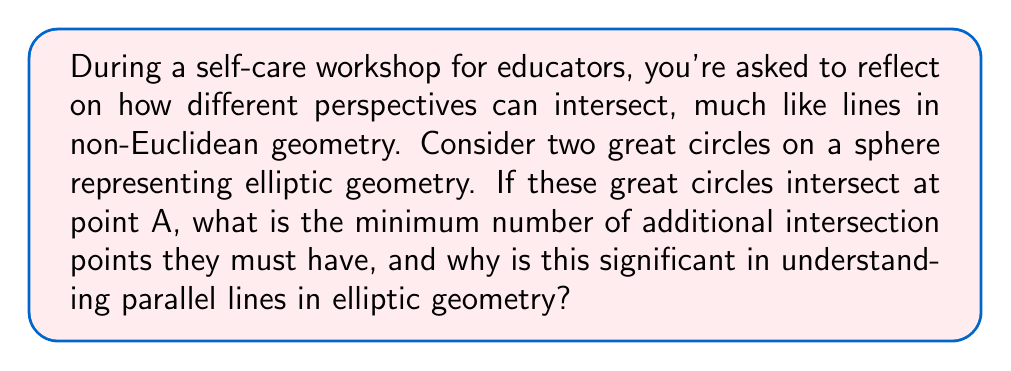Teach me how to tackle this problem. Let's approach this step-by-step:

1. In elliptic geometry, "straight lines" are represented by great circles on a sphere.

2. Two distinct great circles on a sphere always intersect at exactly two points. This is because:

   a) A great circle is formed by the intersection of a plane passing through the center of the sphere with the sphere's surface.
   
   b) Two distinct planes passing through the center of a sphere will always intersect in a line.
   
   c) This line of intersection will pierce the sphere's surface at exactly two points, which are antipodal (diametrically opposite).

3. Given that the two great circles already intersect at point A, there must be exactly one more intersection point, let's call it B, which is antipodal to A.

4. This property is significant in understanding parallel lines in elliptic geometry because:

   a) In Euclidean geometry, parallel lines never intersect.
   
   b) In elliptic geometry, the concept of parallel lines as we know it in Euclidean geometry doesn't exist.
   
   c) Any two "lines" (great circles) in elliptic geometry will always intersect at two points.

5. This can be represented mathematically. If we consider the sphere to have radius $r$ and center at the origin, and point A has coordinates $(x, y, z)$, then point B will have coordinates $(-x, -y, -z)$.

6. The angle $\theta$ between these great circles at their intersection points is given by:

   $$\cos \theta = \frac{|\vec{n_1} \cdot \vec{n_2}|}{|\vec{n_1}||\vec{n_2}|}$$

   where $\vec{n_1}$ and $\vec{n_2}$ are the normal vectors to the planes containing the great circles.

This property of elliptic geometry challenges our Euclidean intuitions and encourages us to consider different perspectives, much like the goal of a self-care workshop for educators.
Answer: 1 additional intersection point 